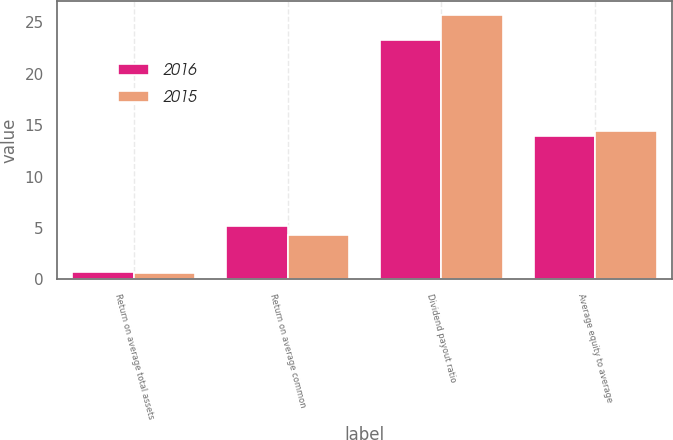<chart> <loc_0><loc_0><loc_500><loc_500><stacked_bar_chart><ecel><fcel>Return on average total assets<fcel>Return on average common<fcel>Dividend payout ratio<fcel>Average equity to average<nl><fcel>2016<fcel>0.73<fcel>5.23<fcel>23.3<fcel>13.93<nl><fcel>2015<fcel>0.62<fcel>4.3<fcel>25.73<fcel>14.46<nl></chart> 